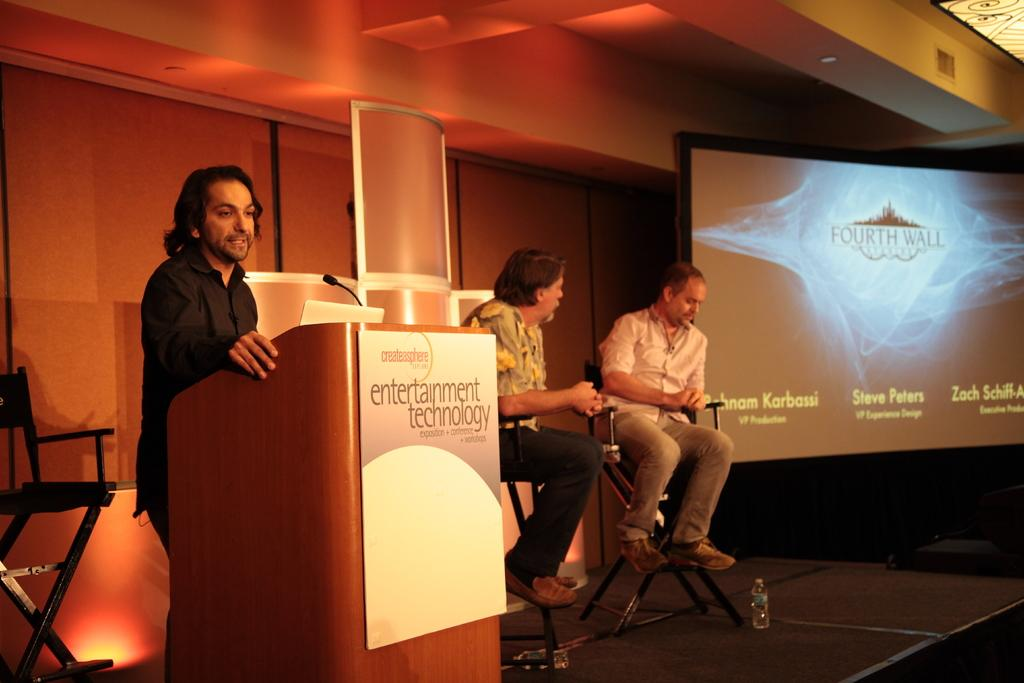<image>
Give a short and clear explanation of the subsequent image. An exposition conference centers around the subject matter of entertainment technology. 